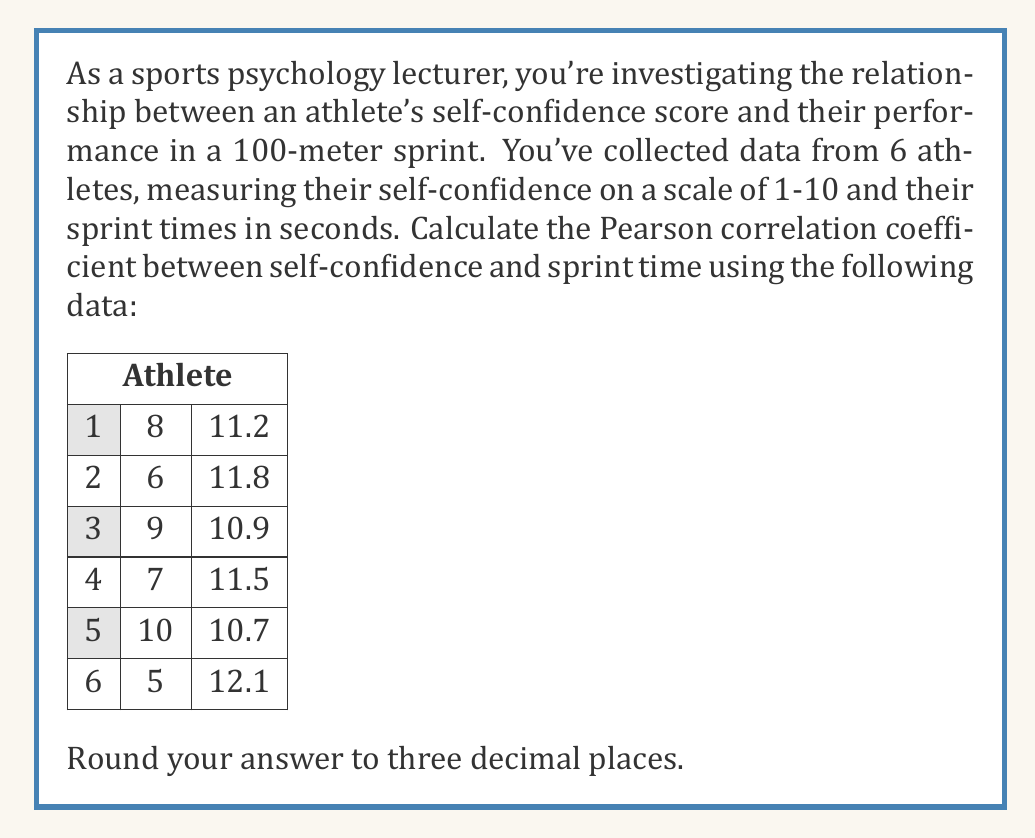Help me with this question. To calculate the Pearson correlation coefficient (r), we'll use the formula:

$$ r = \frac{\sum_{i=1}^{n} (x_i - \bar{x})(y_i - \bar{y})}{\sqrt{\sum_{i=1}^{n} (x_i - \bar{x})^2 \sum_{i=1}^{n} (y_i - \bar{y})^2}} $$

Where $x_i$ and $y_i$ are the individual values, and $\bar{x}$ and $\bar{y}$ are the means of X and Y respectively.

Step 1: Calculate means
$\bar{x} = \frac{8 + 6 + 9 + 7 + 10 + 5}{6} = 7.5$
$\bar{y} = \frac{11.2 + 11.8 + 10.9 + 11.5 + 10.7 + 12.1}{6} = 11.367$

Step 2: Calculate $(x_i - \bar{x})$, $(y_i - \bar{y})$, $(x_i - \bar{x})^2$, $(y_i - \bar{y})^2$, and $(x_i - \bar{x})(y_i - \bar{y})$ for each data point.

Step 3: Sum up the calculated values:
$\sum (x_i - \bar{x})(y_i - \bar{y}) = -3.535$
$\sum (x_i - \bar{x})^2 = 16.5$
$\sum (y_i - \bar{y})^2 = 1.36335$

Step 4: Apply the formula:

$$ r = \frac{-3.535}{\sqrt{16.5 \times 1.36335}} = -0.7561 $$

Step 5: Round to three decimal places: -0.756
Answer: -0.756 